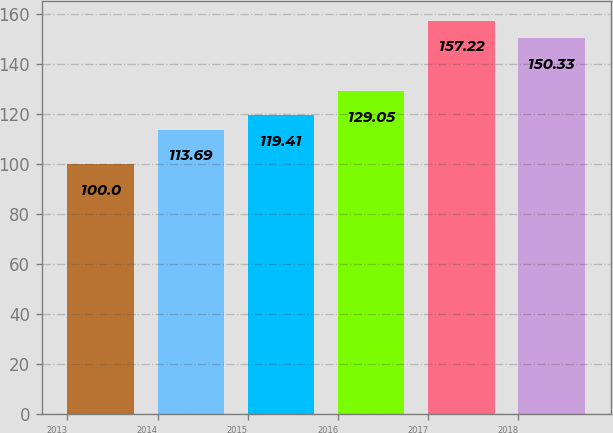Convert chart to OTSL. <chart><loc_0><loc_0><loc_500><loc_500><bar_chart><fcel>2013<fcel>2014<fcel>2015<fcel>2016<fcel>2017<fcel>2018<nl><fcel>100<fcel>113.69<fcel>119.41<fcel>129.05<fcel>157.22<fcel>150.33<nl></chart> 